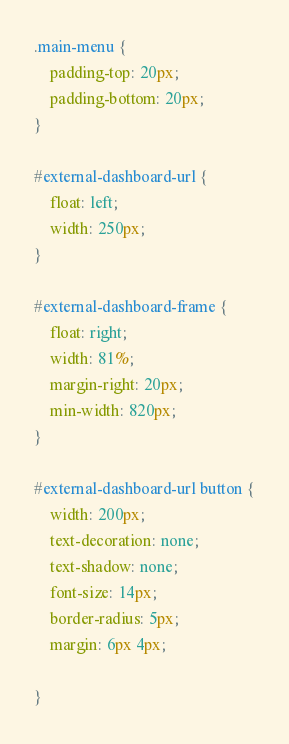Convert code to text. <code><loc_0><loc_0><loc_500><loc_500><_CSS_>.main-menu {
    padding-top: 20px;
    padding-bottom: 20px;
}

#external-dashboard-url {
    float: left;
    width: 250px;
}

#external-dashboard-frame {
    float: right;
    width: 81%;
    margin-right: 20px;
    min-width: 820px;
}

#external-dashboard-url button {
    width: 200px;
    text-decoration: none;
    text-shadow: none;
    font-size: 14px;
    border-radius: 5px;
    margin: 6px 4px;

}

</code> 